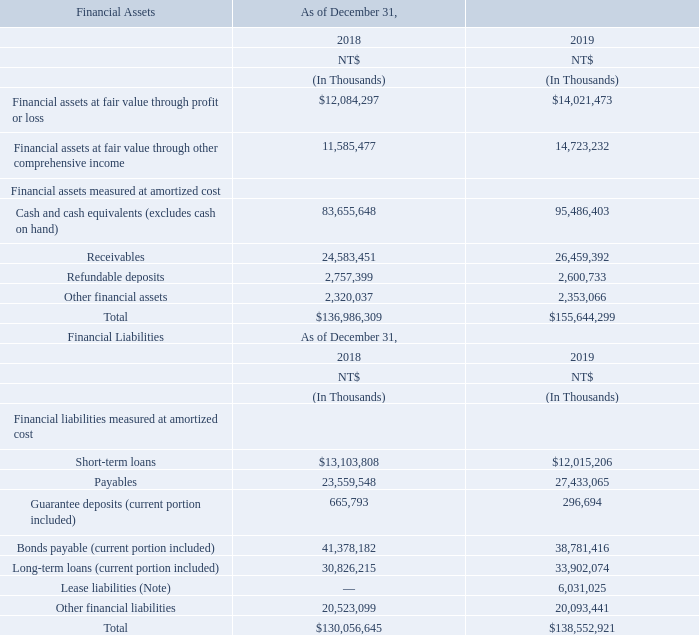Note: The Company adopted IFRS 16 on January 1, 2019. The Company elected not to restate prior periods in accordance with the transition provision in IFRS 16.
Financial risk management objectives and policies
The Company’s risk management objectives are to manage the market risk, credit risk and liquidity risk related to its operating activities. The Company identifies, measures and manages the aforementioned risks based on policy and risk preference.
The Company has established appropriate policies, procedures and internal controls for financial risk management. Before entering into significant financial activities, approval process by the Board of Directors and Audit Committee must be carried out based on related protocols and internal control procedures. The Company complies with its financial risk management policies at all times.
When did the company adopt IFRS 16? January 1, 2019. What are the company's risk management objectives? To manage the market risk, credit risk and liquidity risk related to its operating activities. What were the Financial assets at fair value through profit or loss in 2018?
Answer scale should be: thousand. $12,084,297. What is the increase / (decrease) in the Financial assets at fair value through profit or loss from 2018 to 2019?
Answer scale should be: thousand. 14,021,473 - 12,084,297
Answer: 1937176. What is the increase / (decrease) in the Short-term loans from 2018 to 2019?
Answer scale should be: thousand. 12,015,206 - 13,103,808
Answer: -1088602. What is the percentage change of Other financial assets from 2018 to 2019?
Answer scale should be: percent. 2,353,066 / 2,320,037 - 1
Answer: 1.42. 